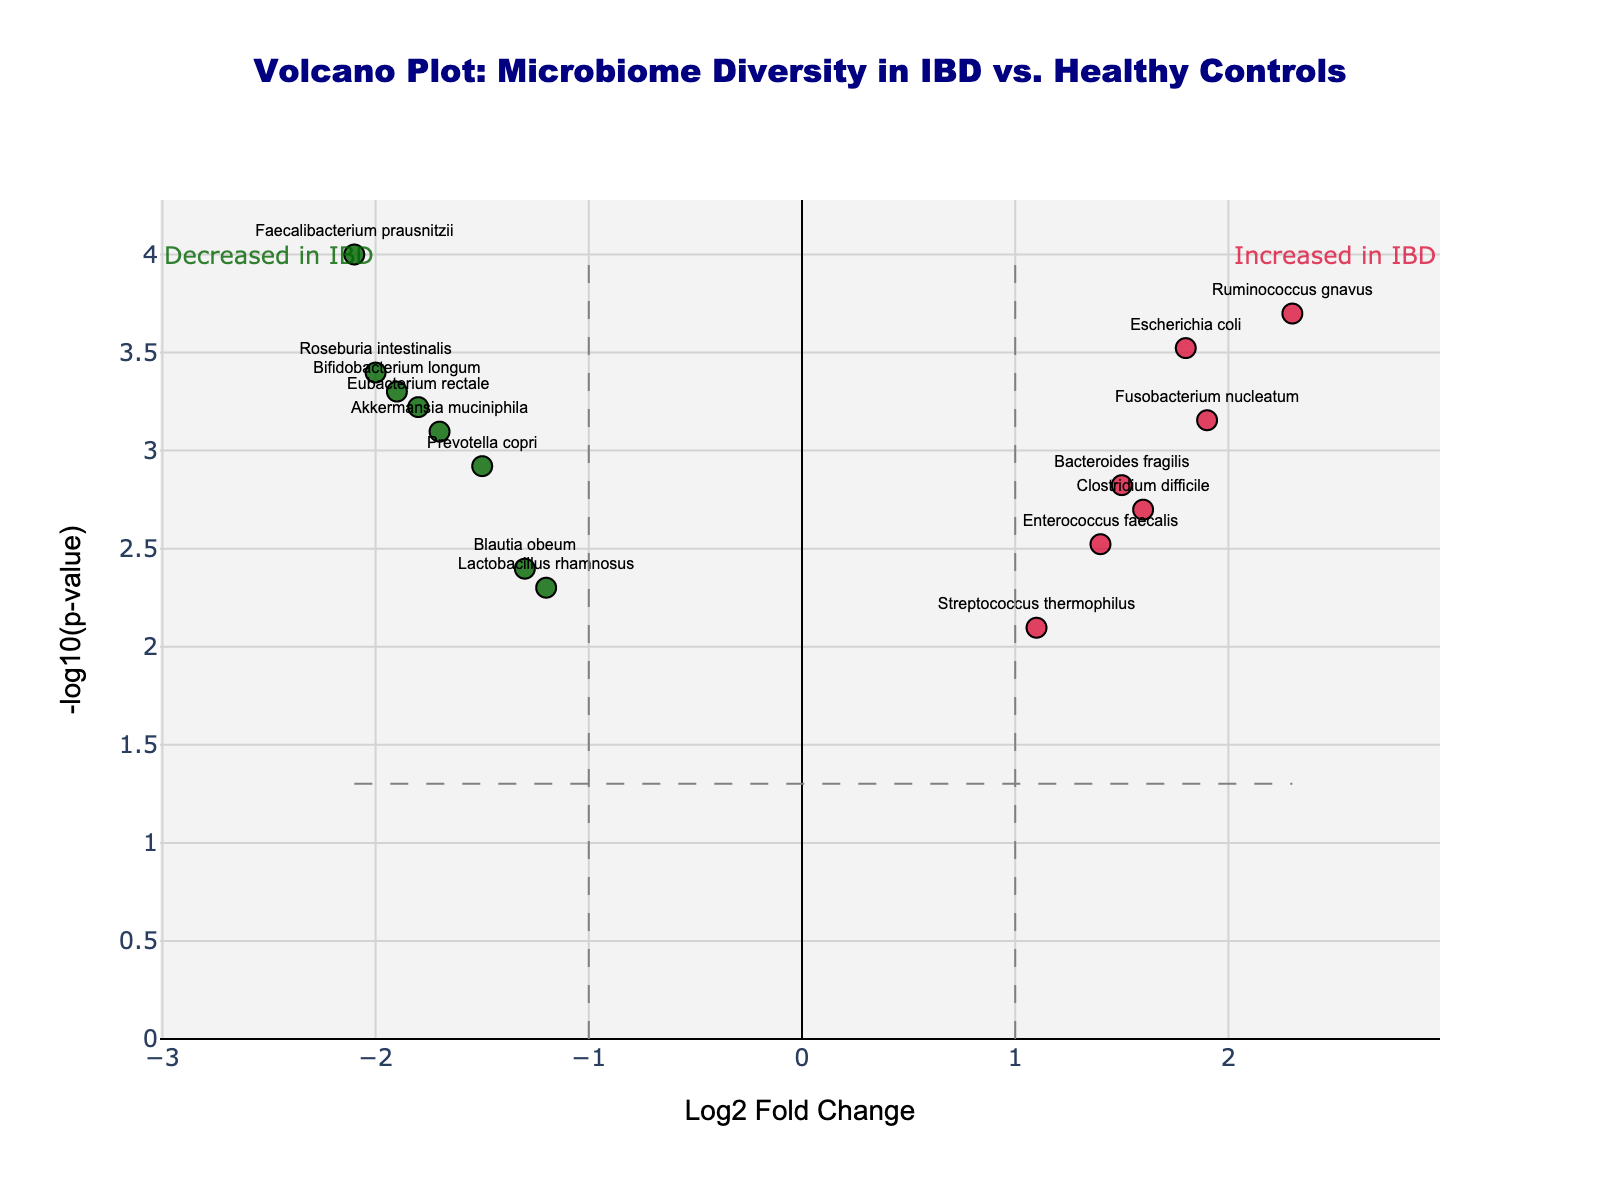What is the title of the figure? The title of the figure is usually displayed at the top center of the plot. In this case, it reads "Volcano Plot: Microbiome Diversity in IBD vs. Healthy Controls".
Answer: Volcano Plot: Microbiome Diversity in IBD vs. Healthy Controls What are the labels of the x-axis and y-axis? The labels are displayed along the x-axis and y-axis of the plot. Here, the x-axis is labeled "Log2 Fold Change" and the y-axis is labeled "-log10(p-value)".
Answer: Log2 Fold Change and -log10(p-value) How many species have a p-value less than 0.005? The horizontal threshold line on the figure represents a p-value of 0.05. All points above this line have a p-value less than 0.05. By counting the number of species above an imaginary line representing a p-value of 0.005, we find that there are 11 species.
Answer: 11 Which species has the highest -log10(p-value)? To find this, we look for the point that is farthest up on the y-axis. This species is "Faecalibacterium prausnitzii".
Answer: Faecalibacterium prausnitzii Which species shows the greatest decrease in abundance in IBD patients compared to healthy controls? The species with the greatest decrease in abundance will have the most negative Log2 Fold Change value. This is "Faecalibacterium prausnitzii" with a Log2 Fold Change of -2.1.
Answer: Faecalibacterium prausnitzii Which species shows the greatest increase in abundance in IBD patients compared to healthy controls? The species with the greatest increase in abundance will have the highest positive Log2 Fold Change value. This is "Ruminococcus gnavus" with a Log2 Fold Change of 2.3.
Answer: Ruminococcus gnavus How many species show significant changes (Log2 Fold Change > 1 or < -1 and p-value < 0.05) in IBD patients? Significant changes are represented by points that meet both fold change and p-value thresholds. Count the colored dots: there are 13 species showing significant changes.
Answer: 13 Which species have a p-value less than 0.001? Species with a p-value less than 0.001 are above the corresponding y-axis threshold. These species are: "Faecalibacterium prausnitzii", "Escherichia coli", "Ruminococcus gnavus", "Akkermansia muciniphila", "Bifidobacterium longum", "Roseburia intestinalis", and "Eubacterium rectale".
Answer: Faecalibacterium prausnitzii, Escherichia coli, Ruminococcus gnavus, Akkermansia muciniphila, Bifidobacterium longum, Roseburia intestinalis, Eubacterium rectale Which species show increased abundance in IBD and have a p-value < 0.001? To find this, look for the red points (indicating increased abundance) above the y-axis threshold for a p-value of 0.001. These species are "Escherichia coli", "Ruminococcus gnavus", and "Fusobacterium nucleatum".
Answer: Escherichia coli, Ruminococcus gnavus, Fusobacterium nucleatum What color represents species with non-significant changes? By observing the color scheme, non-significant changes are represented by grey points.
Answer: Grey 